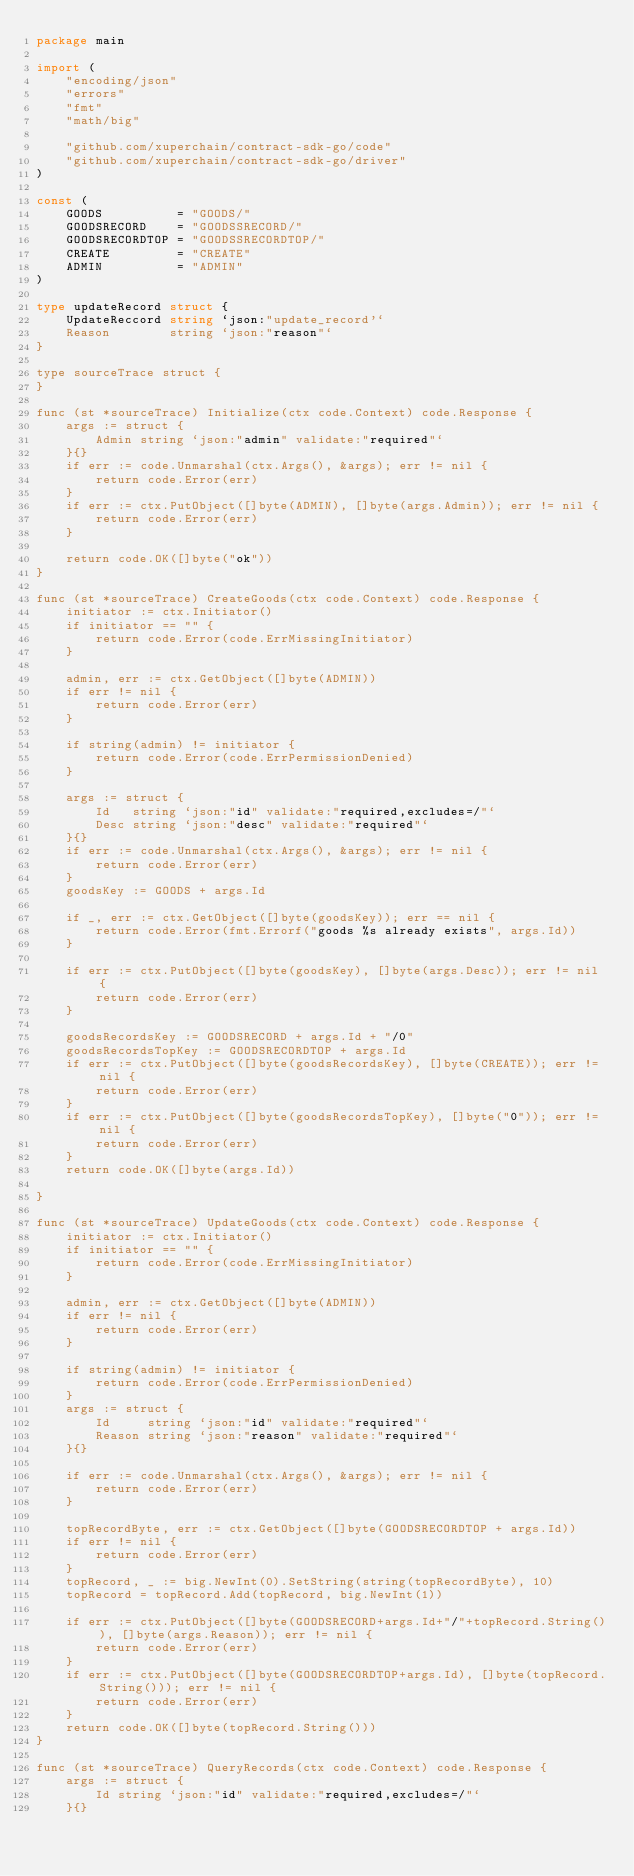<code> <loc_0><loc_0><loc_500><loc_500><_Go_>package main

import (
	"encoding/json"
	"errors"
	"fmt"
	"math/big"

	"github.com/xuperchain/contract-sdk-go/code"
	"github.com/xuperchain/contract-sdk-go/driver"
)

const (
	GOODS          = "GOODS/"
	GOODSRECORD    = "GOODSSRECORD/"
	GOODSRECORDTOP = "GOODSSRECORDTOP/"
	CREATE         = "CREATE"
	ADMIN          = "ADMIN"
)

type updateRecord struct {
	UpdateReccord string `json:"update_record'`
	Reason        string `json:"reason"`
}

type sourceTrace struct {
}

func (st *sourceTrace) Initialize(ctx code.Context) code.Response {
	args := struct {
		Admin string `json:"admin" validate:"required"`
	}{}
	if err := code.Unmarshal(ctx.Args(), &args); err != nil {
		return code.Error(err)
	}
	if err := ctx.PutObject([]byte(ADMIN), []byte(args.Admin)); err != nil {
		return code.Error(err)
	}

	return code.OK([]byte("ok"))
}

func (st *sourceTrace) CreateGoods(ctx code.Context) code.Response {
	initiator := ctx.Initiator()
	if initiator == "" {
		return code.Error(code.ErrMissingInitiator)
	}

	admin, err := ctx.GetObject([]byte(ADMIN))
	if err != nil {
		return code.Error(err)
	}

	if string(admin) != initiator {
		return code.Error(code.ErrPermissionDenied)
	}

	args := struct {
		Id   string `json:"id" validate:"required,excludes=/"`
		Desc string `json:"desc" validate:"required"`
	}{}
	if err := code.Unmarshal(ctx.Args(), &args); err != nil {
		return code.Error(err)
	}
	goodsKey := GOODS + args.Id

	if _, err := ctx.GetObject([]byte(goodsKey)); err == nil {
		return code.Error(fmt.Errorf("goods %s already exists", args.Id))
	}

	if err := ctx.PutObject([]byte(goodsKey), []byte(args.Desc)); err != nil {
		return code.Error(err)
	}

	goodsRecordsKey := GOODSRECORD + args.Id + "/0"
	goodsRecordsTopKey := GOODSRECORDTOP + args.Id
	if err := ctx.PutObject([]byte(goodsRecordsKey), []byte(CREATE)); err != nil {
		return code.Error(err)
	}
	if err := ctx.PutObject([]byte(goodsRecordsTopKey), []byte("0")); err != nil {
		return code.Error(err)
	}
	return code.OK([]byte(args.Id))

}

func (st *sourceTrace) UpdateGoods(ctx code.Context) code.Response {
	initiator := ctx.Initiator()
	if initiator == "" {
		return code.Error(code.ErrMissingInitiator)
	}

	admin, err := ctx.GetObject([]byte(ADMIN))
	if err != nil {
		return code.Error(err)
	}

	if string(admin) != initiator {
		return code.Error(code.ErrPermissionDenied)
	}
	args := struct {
		Id     string `json:"id" validate:"required"`
		Reason string `json:"reason" validate:"required"`
	}{}

	if err := code.Unmarshal(ctx.Args(), &args); err != nil {
		return code.Error(err)
	}

	topRecordByte, err := ctx.GetObject([]byte(GOODSRECORDTOP + args.Id))
	if err != nil {
		return code.Error(err)
	}
	topRecord, _ := big.NewInt(0).SetString(string(topRecordByte), 10)
	topRecord = topRecord.Add(topRecord, big.NewInt(1))

	if err := ctx.PutObject([]byte(GOODSRECORD+args.Id+"/"+topRecord.String()), []byte(args.Reason)); err != nil {
		return code.Error(err)
	}
	if err := ctx.PutObject([]byte(GOODSRECORDTOP+args.Id), []byte(topRecord.String())); err != nil {
		return code.Error(err)
	}
	return code.OK([]byte(topRecord.String()))
}

func (st *sourceTrace) QueryRecords(ctx code.Context) code.Response {
	args := struct {
		Id string `json:"id" validate:"required,excludes=/"`
	}{}</code> 